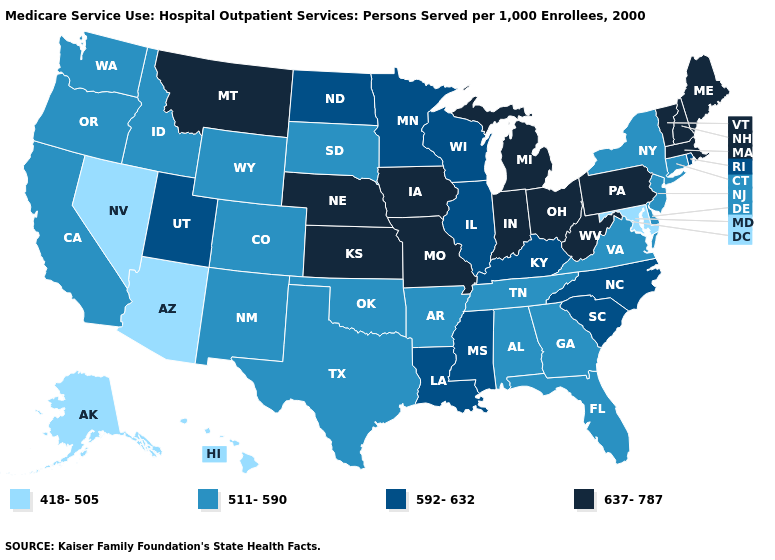Name the states that have a value in the range 511-590?
Give a very brief answer. Alabama, Arkansas, California, Colorado, Connecticut, Delaware, Florida, Georgia, Idaho, New Jersey, New Mexico, New York, Oklahoma, Oregon, South Dakota, Tennessee, Texas, Virginia, Washington, Wyoming. What is the value of New Hampshire?
Be succinct. 637-787. Does South Dakota have the lowest value in the MidWest?
Keep it brief. Yes. What is the lowest value in the USA?
Short answer required. 418-505. Does Wyoming have a lower value than South Carolina?
Write a very short answer. Yes. Which states hav the highest value in the South?
Keep it brief. West Virginia. Does the first symbol in the legend represent the smallest category?
Keep it brief. Yes. Which states have the lowest value in the West?
Keep it brief. Alaska, Arizona, Hawaii, Nevada. Among the states that border Utah , which have the lowest value?
Write a very short answer. Arizona, Nevada. Name the states that have a value in the range 511-590?
Give a very brief answer. Alabama, Arkansas, California, Colorado, Connecticut, Delaware, Florida, Georgia, Idaho, New Jersey, New Mexico, New York, Oklahoma, Oregon, South Dakota, Tennessee, Texas, Virginia, Washington, Wyoming. Does Tennessee have a lower value than Hawaii?
Keep it brief. No. What is the value of Wisconsin?
Keep it brief. 592-632. Among the states that border Indiana , which have the highest value?
Answer briefly. Michigan, Ohio. Among the states that border Texas , which have the lowest value?
Give a very brief answer. Arkansas, New Mexico, Oklahoma. Among the states that border Tennessee , does Mississippi have the lowest value?
Quick response, please. No. 